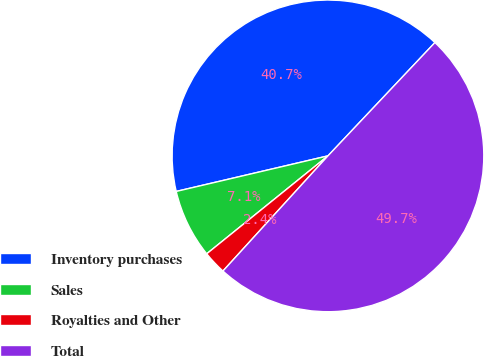Convert chart. <chart><loc_0><loc_0><loc_500><loc_500><pie_chart><fcel>Inventory purchases<fcel>Sales<fcel>Royalties and Other<fcel>Total<nl><fcel>40.71%<fcel>7.15%<fcel>2.42%<fcel>49.73%<nl></chart> 